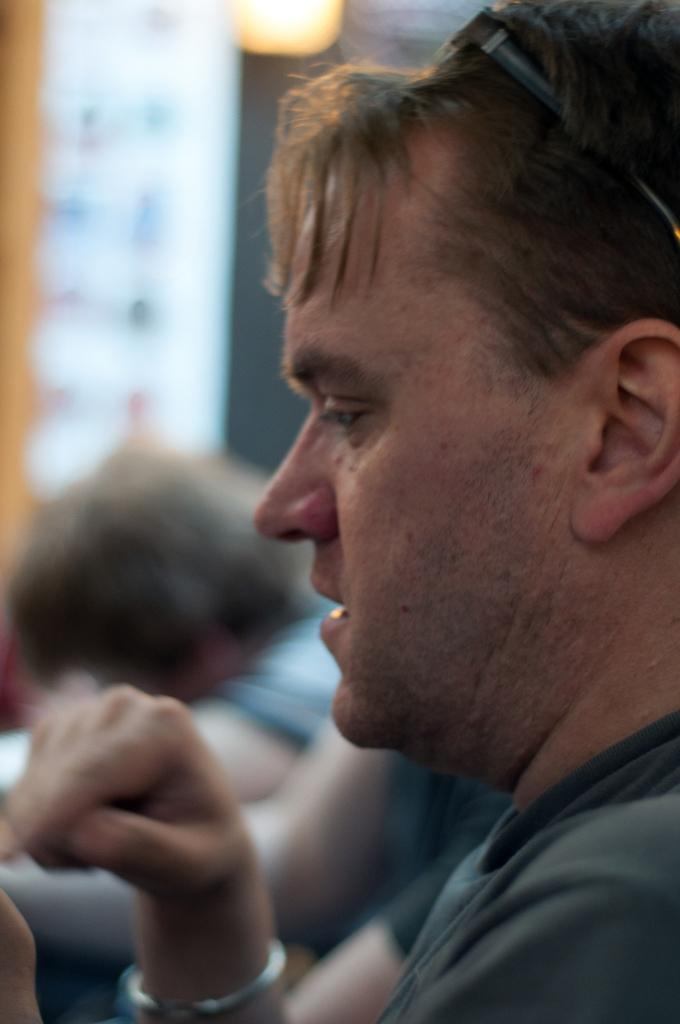Who is the main subject in the image? There is a man in the image. Can you describe the surroundings of the man? There are people in the background of the image. What can be observed about the lighting in the image? There is light visible in the image. What type of box is the man carrying in the image? There is no box present in the image. Is the man planning a trip with the people in the background? The image does not provide any information about a trip or the man's intentions. 